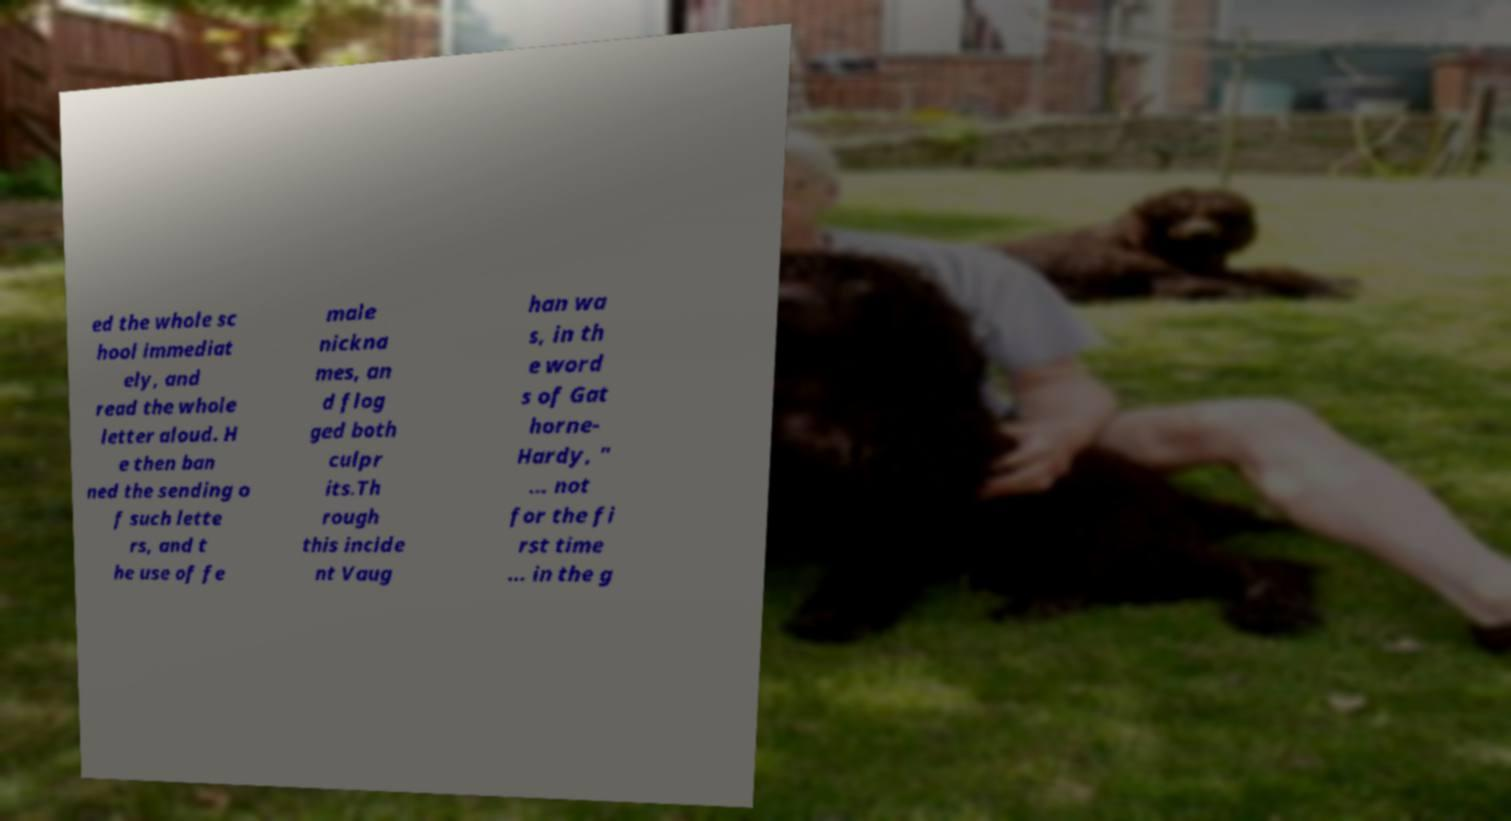Could you assist in decoding the text presented in this image and type it out clearly? ed the whole sc hool immediat ely, and read the whole letter aloud. H e then ban ned the sending o f such lette rs, and t he use of fe male nickna mes, an d flog ged both culpr its.Th rough this incide nt Vaug han wa s, in th e word s of Gat horne- Hardy, " ... not for the fi rst time ... in the g 